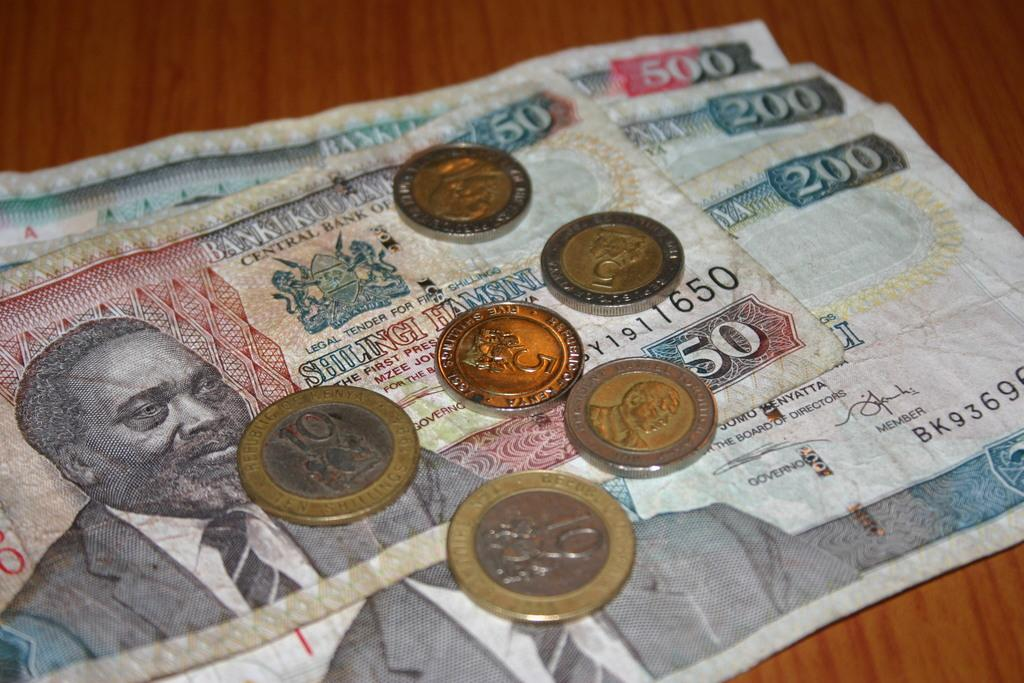<image>
Summarize the visual content of the image. Paper money in denominations of 50, 200 and 500. 